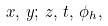<formula> <loc_0><loc_0><loc_500><loc_500>x , \, y ; \, z , \, t , \, \phi _ { h } ,</formula> 